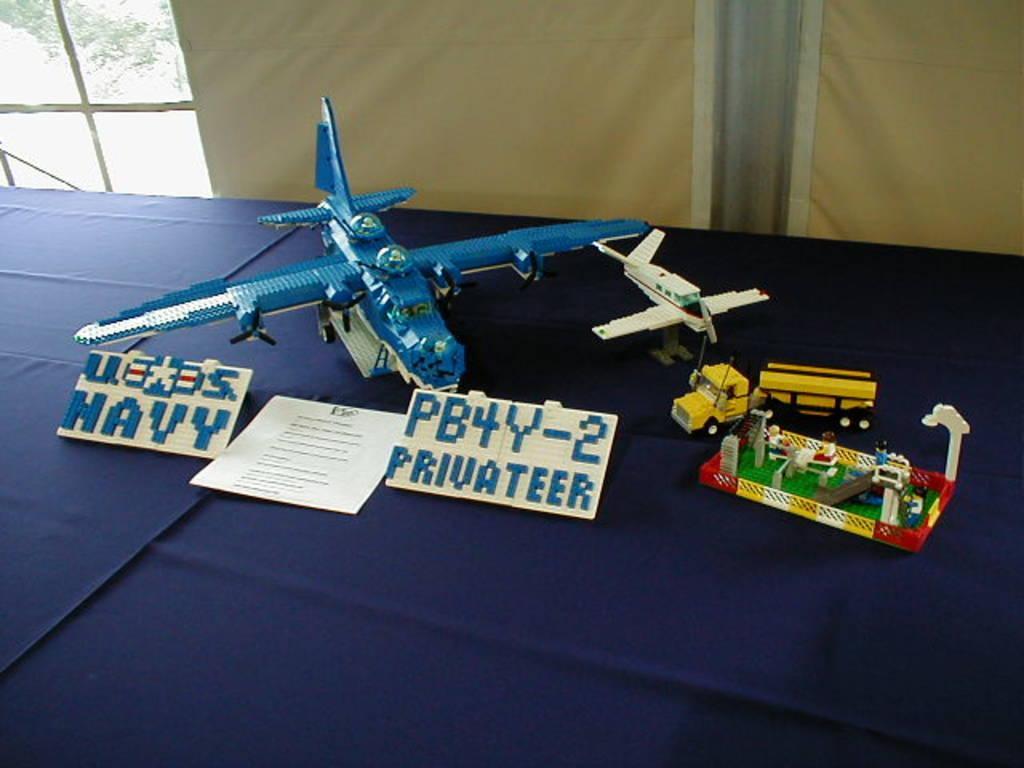Describe this image in one or two sentences. In the background we can see the glass window and a cloth. On a blue cloth we can see toys, paper note with some information and boards. 